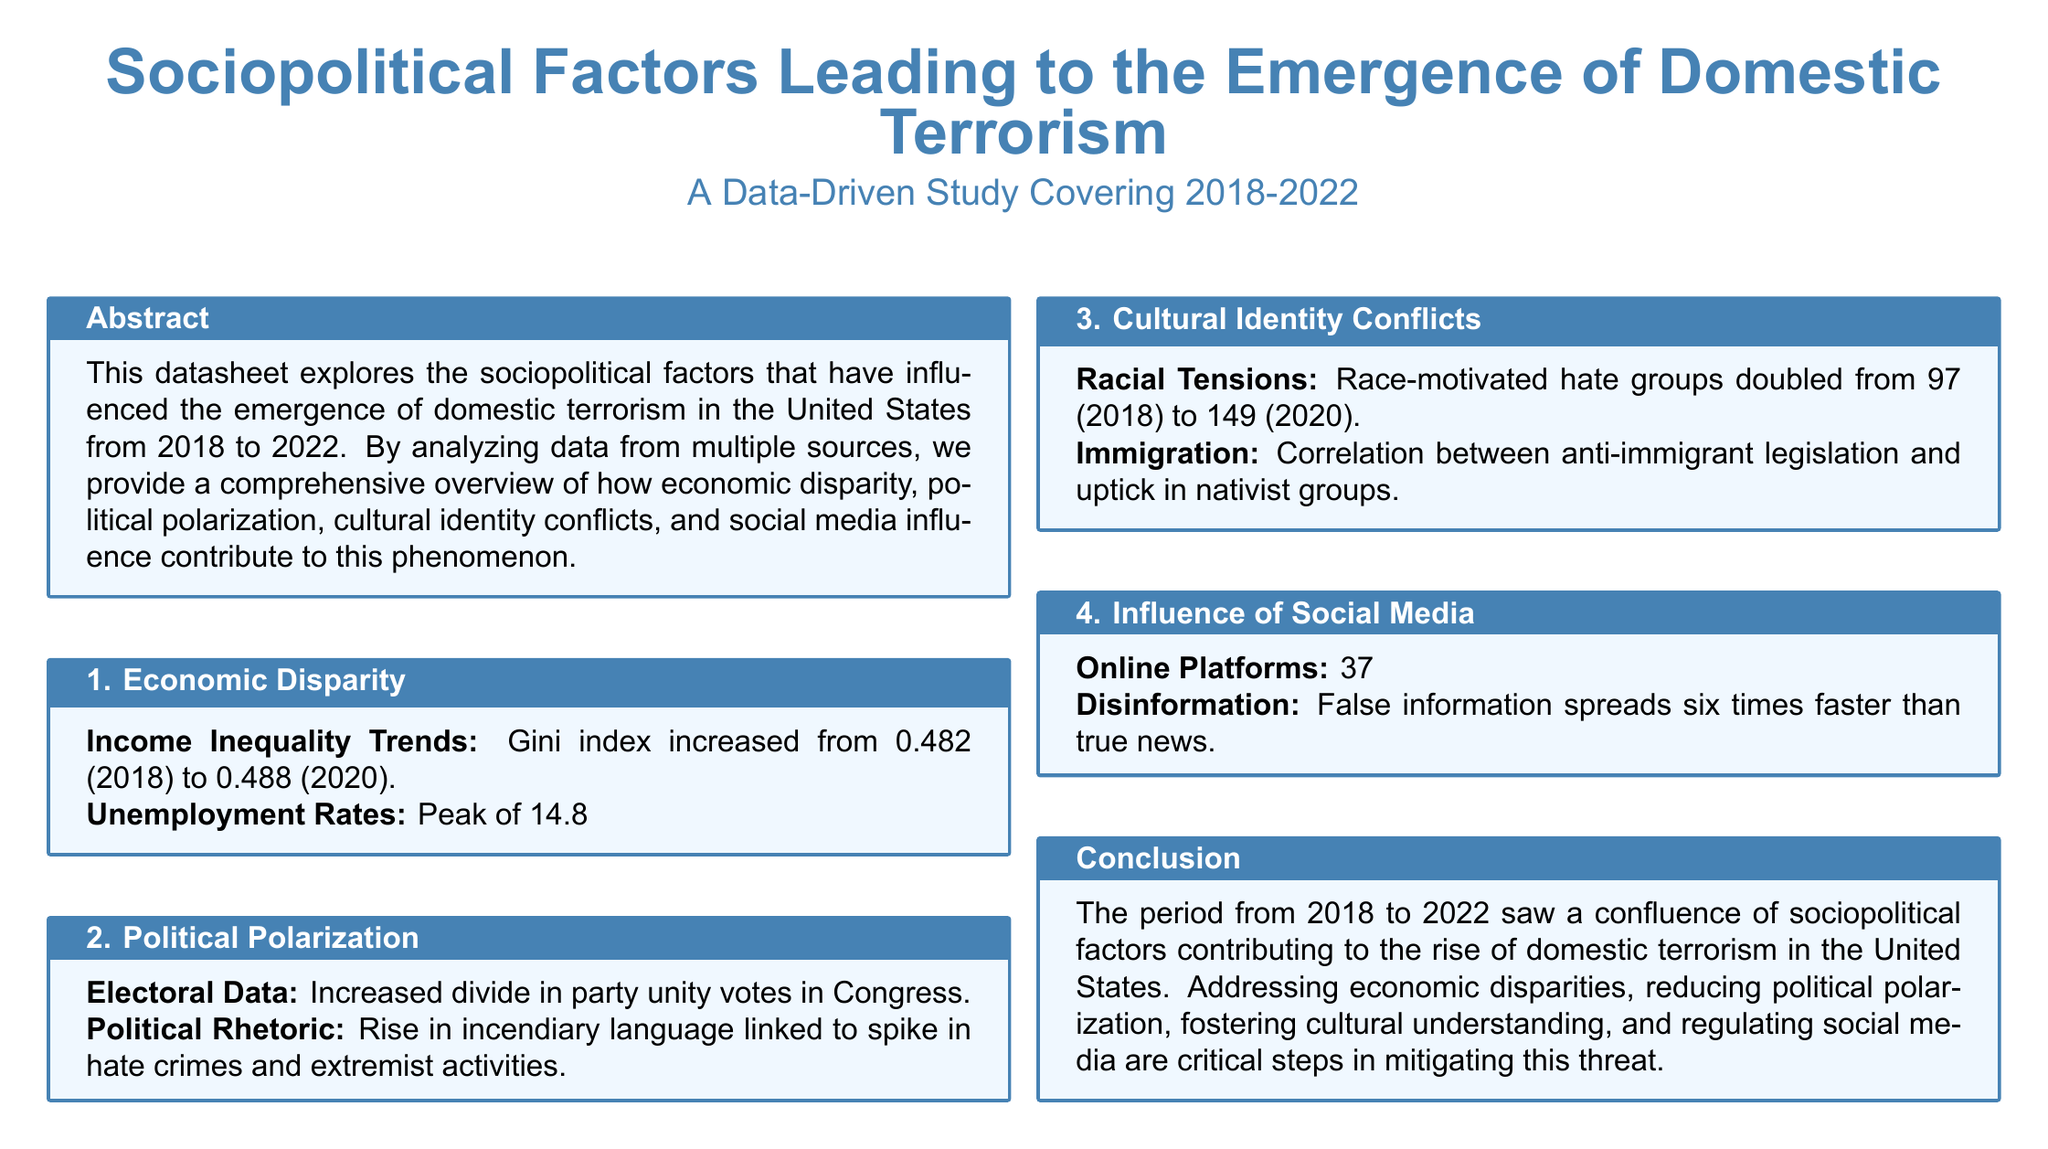What was the Gini index in 2018? The Gini index in 2018 was used to assess income inequality, which was recorded as 0.482.
Answer: 0.482 What was the highest unemployment rate during the COVID-19 pandemic? The highest unemployment rate during this period peaked at 14.8% in April 2020 due to the COVID-19 pandemic.
Answer: 14.8% How many race-motivated hate groups were there in 2020? The document states that race-motivated hate groups doubled in number, resulting in 149 groups in 2020.
Answer: 149 What percentage increase in hate speech posts was noted from 2018 to 2022? The document reports a 37% increase in hate speech posts during this period.
Answer: 37% What correlation was found between legislation and nativist groups? It was noted that there was a correlation between anti-immigrant legislation and an uptick in nativist groups.
Answer: Anti-immigrant legislation What was the trend in incendiary political rhetoric? The document indicates that incendiary language increased and was linked to a spike in hate crimes and extremist activities.
Answer: Increased What was the Gini index in 2020? The Gini index in 2020 was recorded as 0.488.
Answer: 0.488 How much faster does disinformation spread compared to true news? The document mentions that false information spreads six times faster than true news.
Answer: Six times faster What is a necessary step to mitigate domestic terrorism threats? The document lists reducing political polarization as a critical step in mitigating this threat.
Answer: Reducing political polarization 